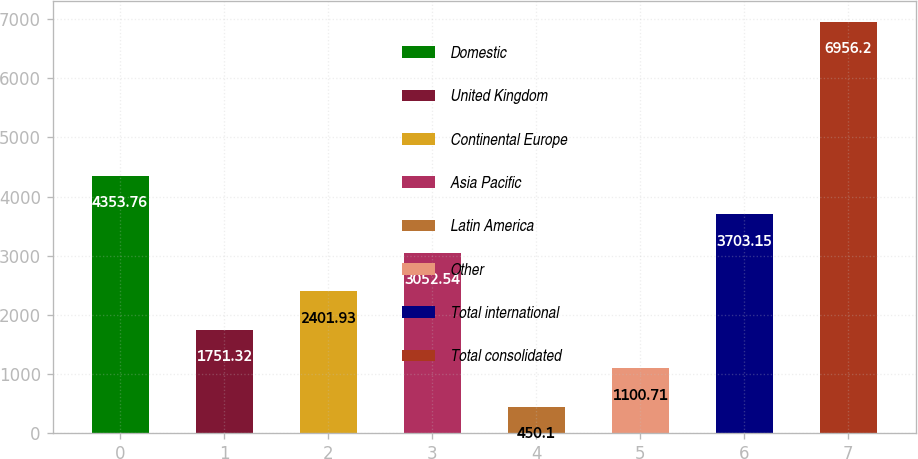Convert chart to OTSL. <chart><loc_0><loc_0><loc_500><loc_500><bar_chart><fcel>Domestic<fcel>United Kingdom<fcel>Continental Europe<fcel>Asia Pacific<fcel>Latin America<fcel>Other<fcel>Total international<fcel>Total consolidated<nl><fcel>4353.76<fcel>1751.32<fcel>2401.93<fcel>3052.54<fcel>450.1<fcel>1100.71<fcel>3703.15<fcel>6956.2<nl></chart> 